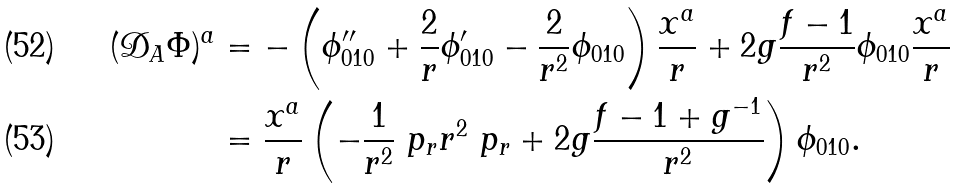<formula> <loc_0><loc_0><loc_500><loc_500>( \mathcal { D } _ { A } \Phi ) ^ { a } & = - \left ( \phi ^ { \prime \prime } _ { 0 1 0 } + \frac { 2 } { r } \phi ^ { \prime } _ { 0 1 0 } - \frac { 2 } { r ^ { 2 } } \phi _ { 0 1 0 } \right ) \frac { x ^ { a } } { r } + 2 g \frac { f - 1 } { r ^ { 2 } } \phi _ { 0 1 0 } \frac { x ^ { a } } { r } \\ & = \frac { x ^ { a } } { r } \left ( - \frac { 1 } { r ^ { 2 } } \ p _ { r } r ^ { 2 } \ p _ { r } + 2 g \frac { f - 1 + g ^ { - 1 } } { r ^ { 2 } } \right ) \phi _ { 0 1 0 } .</formula> 